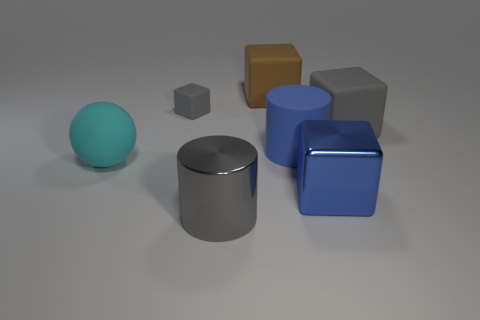Add 2 shiny cubes. How many objects exist? 9 Subtract all cylinders. How many objects are left? 5 Subtract 0 blue spheres. How many objects are left? 7 Subtract all matte spheres. Subtract all shiny cylinders. How many objects are left? 5 Add 4 gray rubber objects. How many gray rubber objects are left? 6 Add 2 blue things. How many blue things exist? 4 